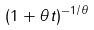Convert formula to latex. <formula><loc_0><loc_0><loc_500><loc_500>( 1 + \theta t ) ^ { - 1 / \theta }</formula> 